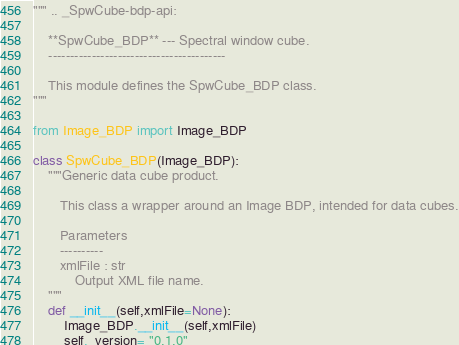Convert code to text. <code><loc_0><loc_0><loc_500><loc_500><_Python_>""" .. _SpwCube-bdp-api:

    **SpwCube_BDP** --- Spectral window cube.
    -----------------------------------------

    This module defines the SpwCube_BDP class.
"""

from Image_BDP import Image_BDP

class SpwCube_BDP(Image_BDP):
    """Generic data cube product.
    
       This class a wrapper around an Image BDP, intended for data cubes.

       Parameters
       ----------
       xmlFile : str
           Output XML file name.
    """
    def __init__(self,xmlFile=None):
        Image_BDP.__init__(self,xmlFile)
        self._version= "0.1.0"
</code> 